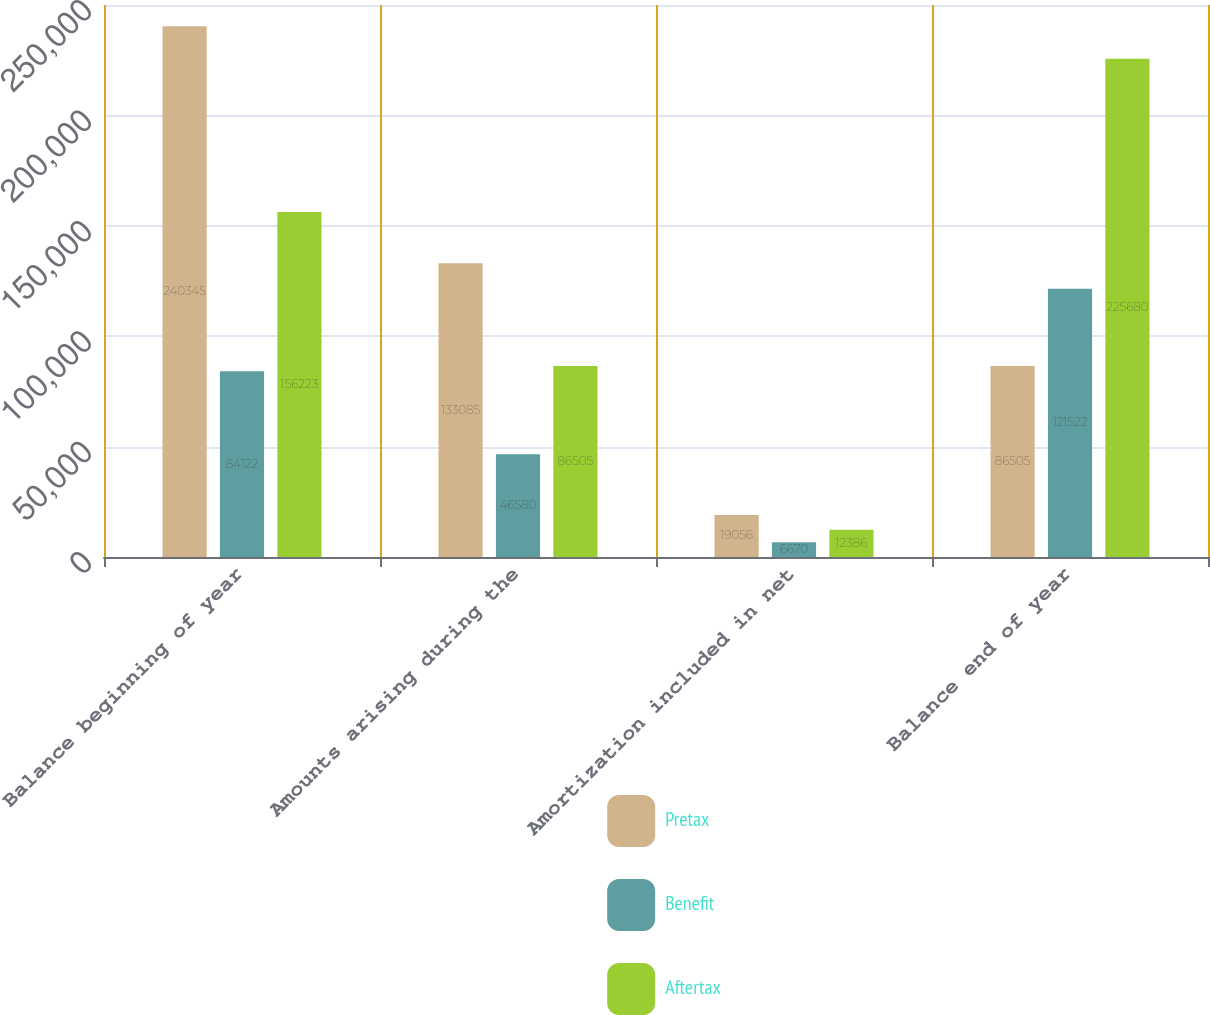Convert chart to OTSL. <chart><loc_0><loc_0><loc_500><loc_500><stacked_bar_chart><ecel><fcel>Balance beginning of year<fcel>Amounts arising during the<fcel>Amortization included in net<fcel>Balance end of year<nl><fcel>Pretax<fcel>240345<fcel>133085<fcel>19056<fcel>86505<nl><fcel>Benefit<fcel>84122<fcel>46580<fcel>6670<fcel>121522<nl><fcel>Aftertax<fcel>156223<fcel>86505<fcel>12386<fcel>225680<nl></chart> 